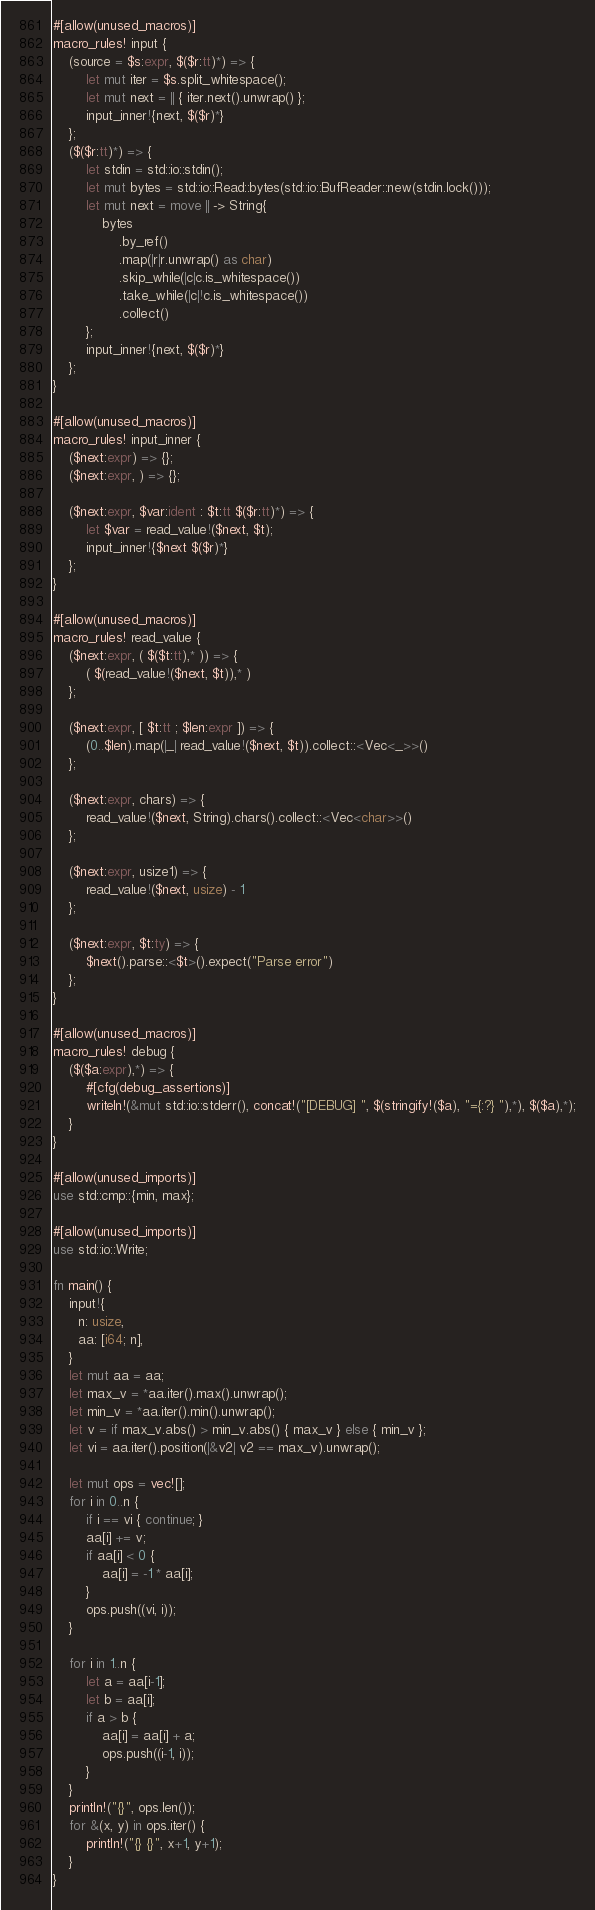<code> <loc_0><loc_0><loc_500><loc_500><_Rust_>#[allow(unused_macros)]
macro_rules! input {
    (source = $s:expr, $($r:tt)*) => {
        let mut iter = $s.split_whitespace();
        let mut next = || { iter.next().unwrap() };
        input_inner!{next, $($r)*}
    };
    ($($r:tt)*) => {
        let stdin = std::io::stdin();
        let mut bytes = std::io::Read::bytes(std::io::BufReader::new(stdin.lock()));
        let mut next = move || -> String{
            bytes
                .by_ref()
                .map(|r|r.unwrap() as char)
                .skip_while(|c|c.is_whitespace())
                .take_while(|c|!c.is_whitespace())
                .collect()
        };
        input_inner!{next, $($r)*}
    };
}

#[allow(unused_macros)]
macro_rules! input_inner {
    ($next:expr) => {};
    ($next:expr, ) => {};

    ($next:expr, $var:ident : $t:tt $($r:tt)*) => {
        let $var = read_value!($next, $t);
        input_inner!{$next $($r)*}
    };
}

#[allow(unused_macros)]
macro_rules! read_value {
    ($next:expr, ( $($t:tt),* )) => {
        ( $(read_value!($next, $t)),* )
    };

    ($next:expr, [ $t:tt ; $len:expr ]) => {
        (0..$len).map(|_| read_value!($next, $t)).collect::<Vec<_>>()
    };

    ($next:expr, chars) => {
        read_value!($next, String).chars().collect::<Vec<char>>()
    };

    ($next:expr, usize1) => {
        read_value!($next, usize) - 1
    };

    ($next:expr, $t:ty) => {
        $next().parse::<$t>().expect("Parse error")
    };
}

#[allow(unused_macros)]
macro_rules! debug {
    ($($a:expr),*) => {
        #[cfg(debug_assertions)]
        writeln!(&mut std::io::stderr(), concat!("[DEBUG] ", $(stringify!($a), "={:?} "),*), $($a),*);
    }
}

#[allow(unused_imports)]
use std::cmp::{min, max};

#[allow(unused_imports)]
use std::io::Write;

fn main() {
    input!{
      n: usize,
      aa: [i64; n],
    }
    let mut aa = aa;
    let max_v = *aa.iter().max().unwrap();
    let min_v = *aa.iter().min().unwrap();
    let v = if max_v.abs() > min_v.abs() { max_v } else { min_v };
    let vi = aa.iter().position(|&v2| v2 == max_v).unwrap();

    let mut ops = vec![];
    for i in 0..n {
        if i == vi { continue; }
        aa[i] += v;
        if aa[i] < 0 {
            aa[i] = -1 * aa[i];
        }
        ops.push((vi, i));
    }

    for i in 1..n {
        let a = aa[i-1];
        let b = aa[i];
        if a > b {
            aa[i] = aa[i] + a;
            ops.push((i-1, i));
        }
    }
    println!("{}", ops.len());
    for &(x, y) in ops.iter() {
        println!("{} {}", x+1, y+1);
    }
}
</code> 